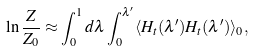<formula> <loc_0><loc_0><loc_500><loc_500>\ln \frac { Z } { Z _ { 0 } } \approx \int _ { 0 } ^ { 1 } d \lambda \int _ { 0 } ^ { \lambda ^ { \prime } } \langle H _ { t } ( \lambda ^ { \prime } ) H _ { t } ( \lambda ^ { \prime } ) \rangle _ { 0 } ,</formula> 